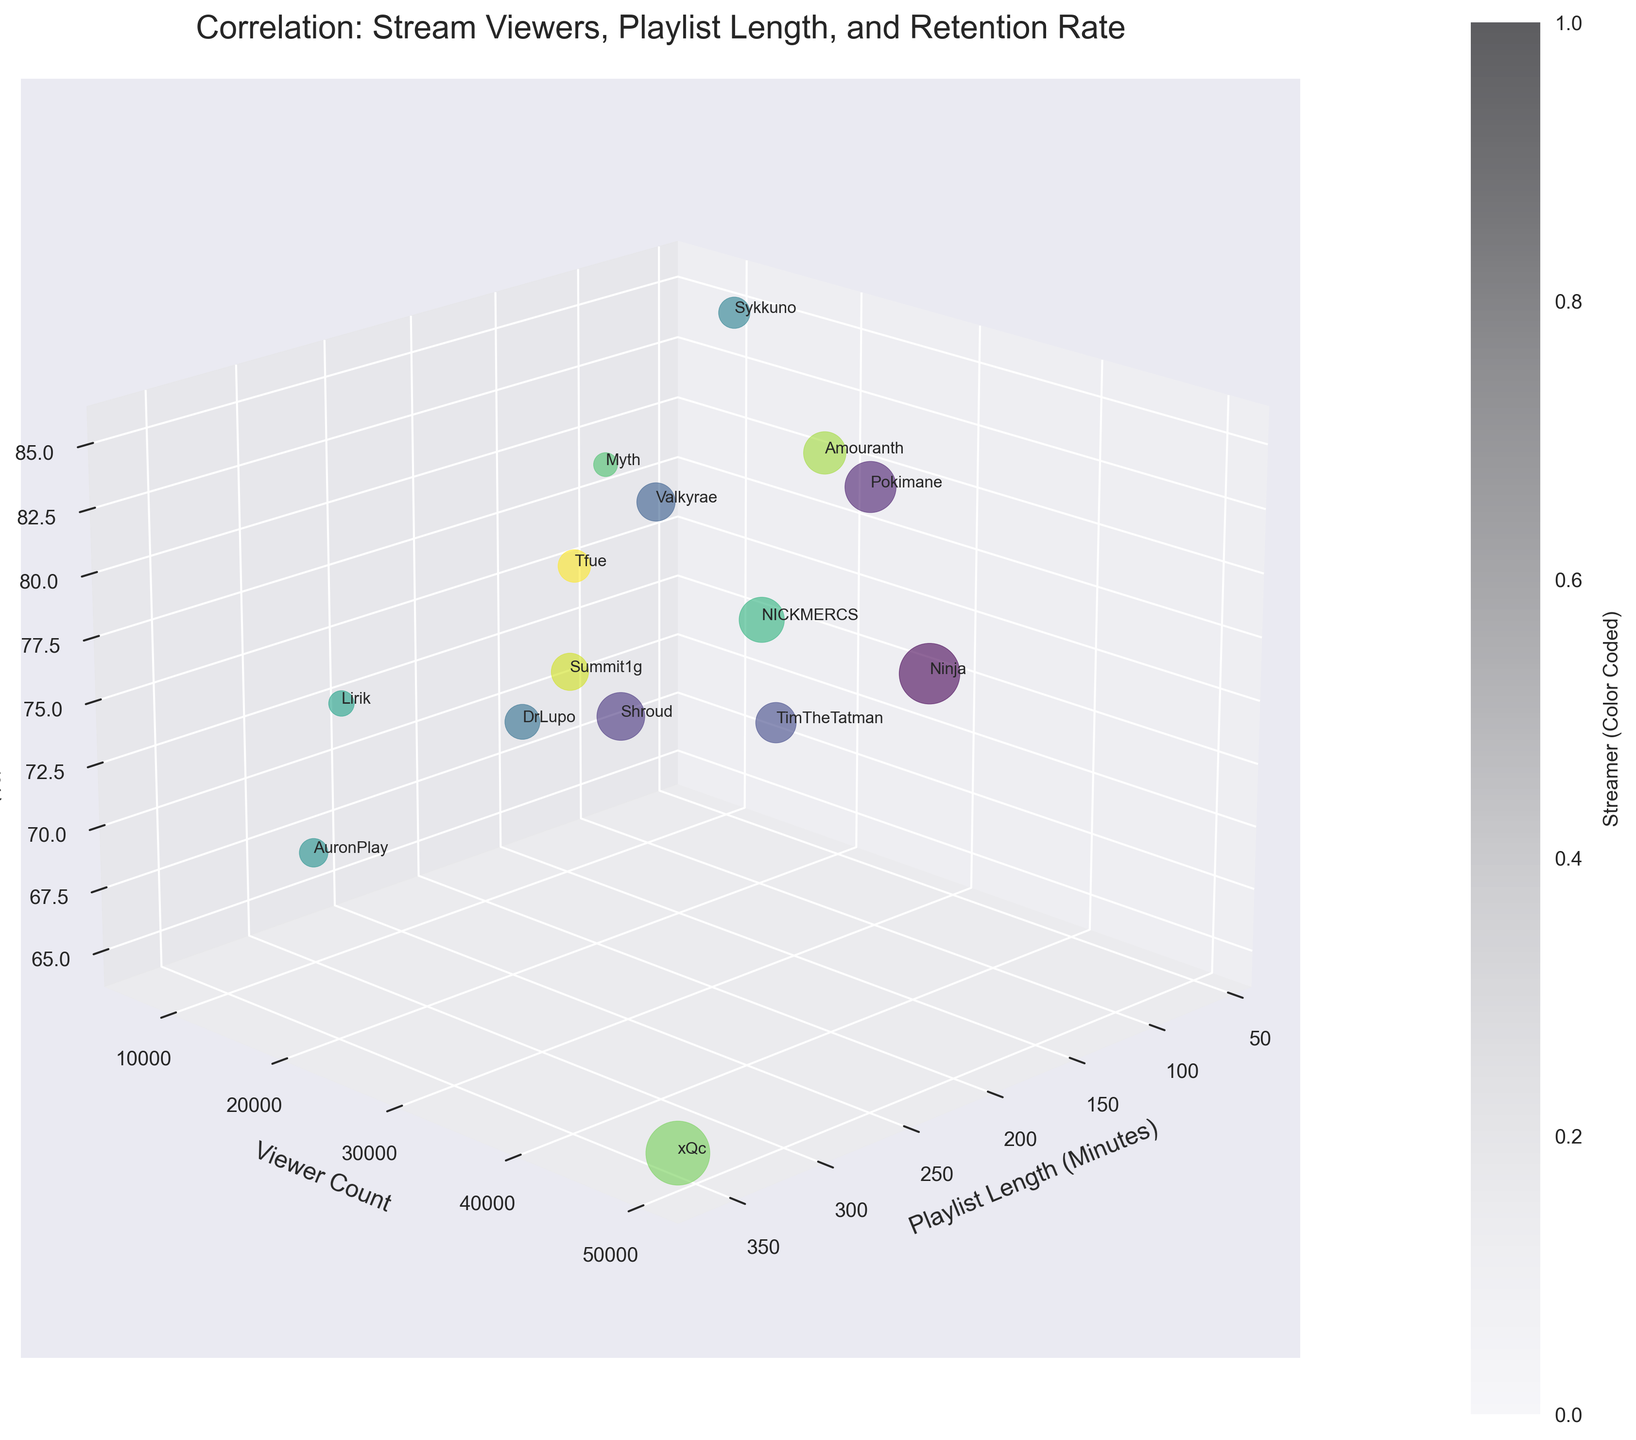How many data points are on the plot? The plot represents each streamer as a data point. By counting the number of streamers listed in the dataset, we find that there are 15 streamers. Therefore, there are 15 data points on the plot.
Answer: 15 What axis represents the viewer count? Observing the plot, the vertical axis is labeled as 'Viewer Count'. This means the y-axis (vertical axis) represents the viewer count in the figure.
Answer: y-axis Which streamer has the shortest playlist length? To find the streamer with the shortest playlist length, we look at the points along the x-axis (Playlist Length). 'Sykkuno' is positioned farthest to the left, indicating the shortest playlist length of 60 minutes.
Answer: Sykkuno Comparing 'Ninja' and 'xQc', who has a higher retention rate? Looking at the z-axis (Retention Rate) positions of 'Ninja' and 'xQc', 'Ninja' is positioned higher on the z-axis, implying a higher retention rate compared to 'xQc'.
Answer: Ninja Who has the highest viewer count and what is the retention rate for that streamer? The highest point on the y-axis (Viewer Count) is 'xQc' with a viewer count of 50,000. The corresponding point along the z-axis indicates his retention rate at 65%.
Answer: xQc, 65% Is there a trend between playlist length and viewer retention rate? To determine the trend, we can visually inspect the plot. Most points do not seem to follow a consistent pattern indicating changes in retention rate based on playlist length. Some with longer playlist lengths have low retention rates, while others with varying lengths have higher retention rates.
Answer: No consistent trend Which genre is represented by the streamer with the lowest retention rate? By identifying the lowest point on the z-axis (Retention Rate), we find that 'xQc' has the lowest retention rate. His genre, as per the data, is 'Variety'.
Answer: Variety What axis shows the playlist length, and how is it visually represented? The axis representing 'Playlist Length' is the x-axis, which is labeled as 'Playlist Length (Minutes)'. Each streamer's playlist length is plotted along this horizontal axis.
Answer: x-axis Which streamer has a playlist length of exactly 180 minutes? Searching the plot for a point situated directly on x=180, we see that 'Ninja' is the corresponding streamer with this playlist length.
Answer: Ninja If you sum the viewer counts of 'Pokimane' and 'Myth', what is the total? Adding the viewer counts of 'Pokimane' (32,000) and 'Myth' (7,000), we get: 32,000 + 7,000 = 39,000. Therefore, the total viewer count for both is 39,000.
Answer: 39,000 